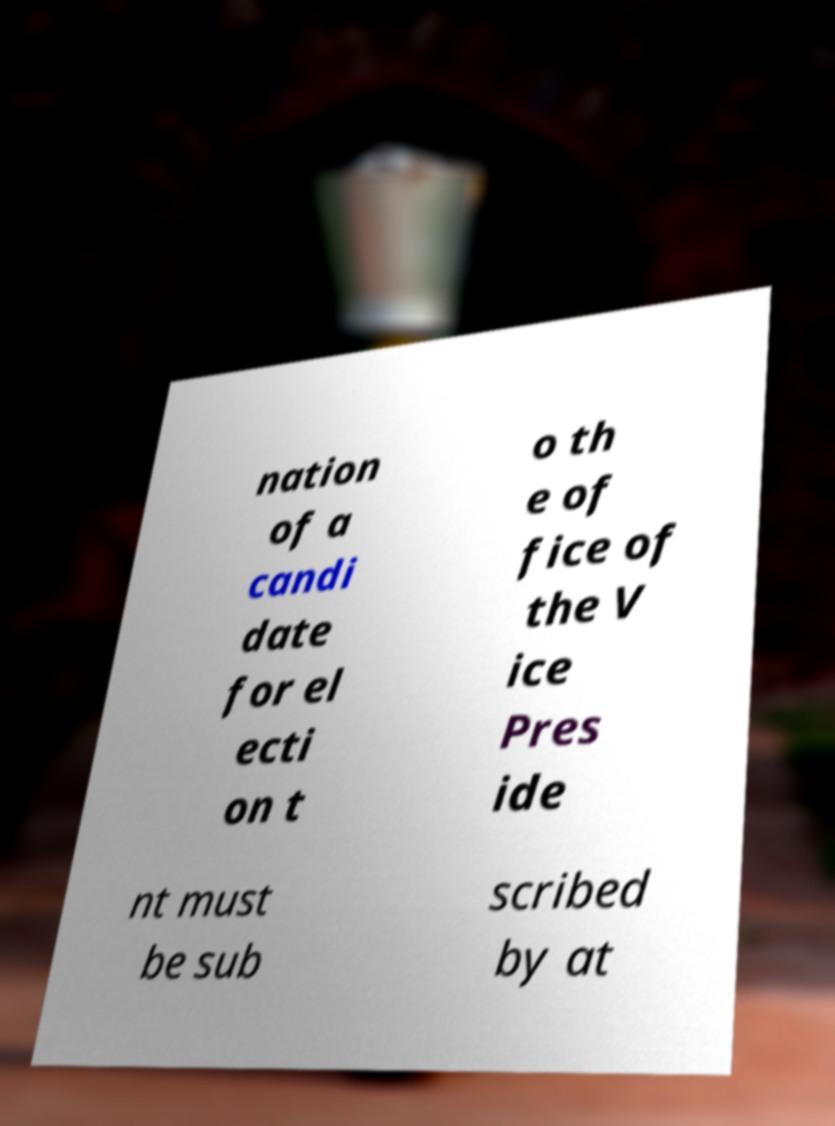There's text embedded in this image that I need extracted. Can you transcribe it verbatim? nation of a candi date for el ecti on t o th e of fice of the V ice Pres ide nt must be sub scribed by at 